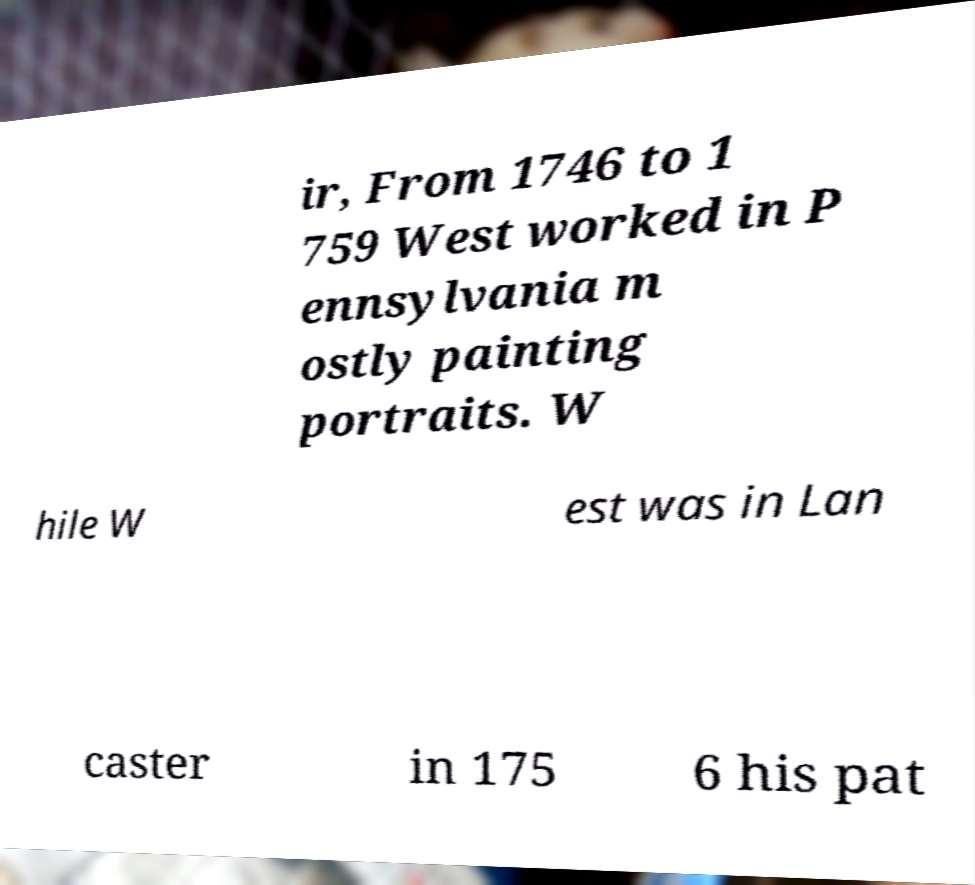Please identify and transcribe the text found in this image. ir, From 1746 to 1 759 West worked in P ennsylvania m ostly painting portraits. W hile W est was in Lan caster in 175 6 his pat 